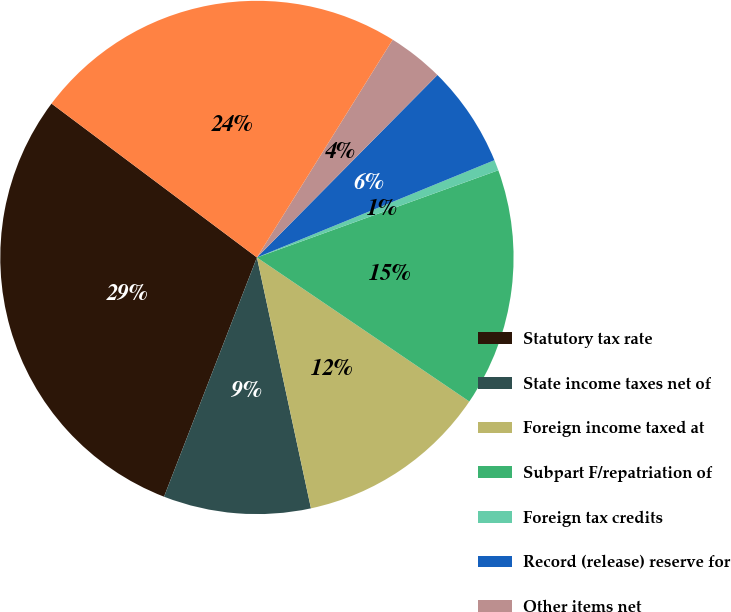<chart> <loc_0><loc_0><loc_500><loc_500><pie_chart><fcel>Statutory tax rate<fcel>State income taxes net of<fcel>Foreign income taxed at<fcel>Subpart F/repatriation of<fcel>Foreign tax credits<fcel>Record (release) reserve for<fcel>Other items net<fcel>Effective tax rate<nl><fcel>29.34%<fcel>9.27%<fcel>12.14%<fcel>15.0%<fcel>0.67%<fcel>6.4%<fcel>3.54%<fcel>23.64%<nl></chart> 